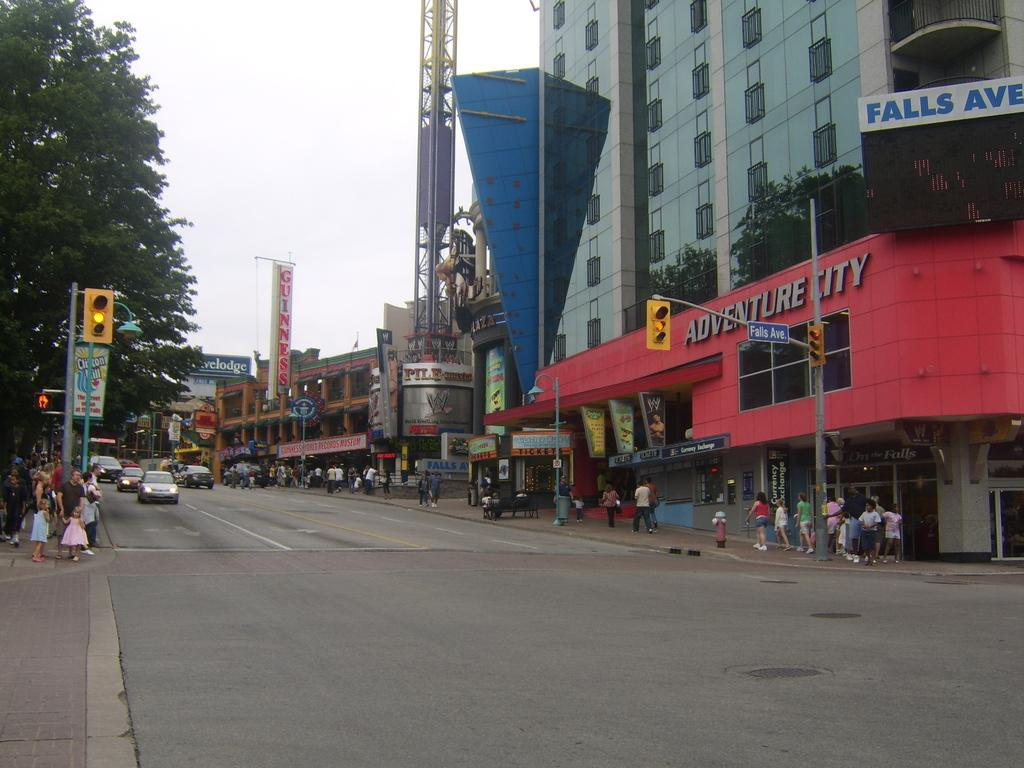What can be seen in the background of the image? The sky is visible in the background of the image. What type of structures are present in the image? There are buildings in the image. What are some other objects that can be seen in the image? There are boards, poles, traffic signals, a banner, vehicles, and other objects in the image. Are there any people present in the image? Yes, there are people in the image. What is the primary surface in the image? There is a road in the image. How many hands are visible in the image? There is no specific mention of hands in the image, so it is not possible to determine how many hands are visible. 